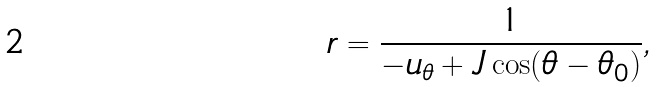<formula> <loc_0><loc_0><loc_500><loc_500>r = \frac { 1 } { - u _ { \theta } + J \cos ( \theta - \theta _ { 0 } ) } ,</formula> 